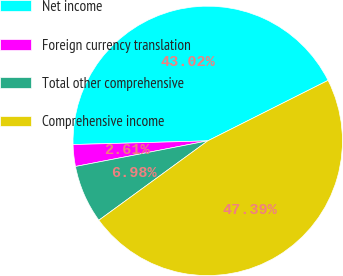<chart> <loc_0><loc_0><loc_500><loc_500><pie_chart><fcel>Net income<fcel>Foreign currency translation<fcel>Total other comprehensive<fcel>Comprehensive income<nl><fcel>43.02%<fcel>2.61%<fcel>6.98%<fcel>47.39%<nl></chart> 